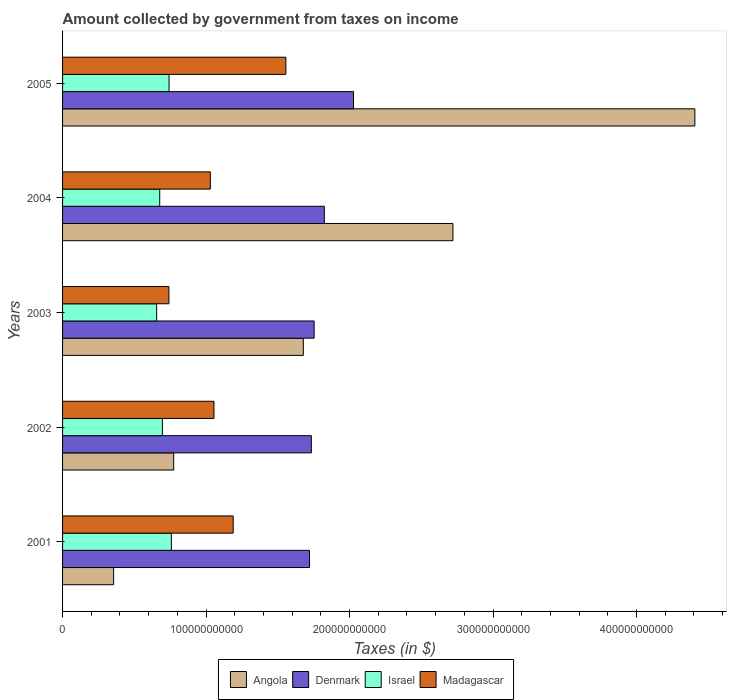How many different coloured bars are there?
Make the answer very short. 4. How many bars are there on the 2nd tick from the top?
Offer a very short reply. 4. How many bars are there on the 2nd tick from the bottom?
Provide a succinct answer. 4. What is the amount collected by government from taxes on income in Denmark in 2003?
Provide a short and direct response. 1.75e+11. Across all years, what is the maximum amount collected by government from taxes on income in Israel?
Your answer should be compact. 7.58e+1. Across all years, what is the minimum amount collected by government from taxes on income in Israel?
Keep it short and to the point. 6.56e+1. In which year was the amount collected by government from taxes on income in Israel maximum?
Give a very brief answer. 2001. What is the total amount collected by government from taxes on income in Denmark in the graph?
Your answer should be very brief. 9.06e+11. What is the difference between the amount collected by government from taxes on income in Denmark in 2003 and that in 2005?
Your answer should be very brief. -2.74e+1. What is the difference between the amount collected by government from taxes on income in Madagascar in 2001 and the amount collected by government from taxes on income in Denmark in 2002?
Give a very brief answer. -5.45e+1. What is the average amount collected by government from taxes on income in Denmark per year?
Ensure brevity in your answer.  1.81e+11. In the year 2004, what is the difference between the amount collected by government from taxes on income in Israel and amount collected by government from taxes on income in Denmark?
Give a very brief answer. -1.15e+11. In how many years, is the amount collected by government from taxes on income in Israel greater than 320000000000 $?
Give a very brief answer. 0. What is the ratio of the amount collected by government from taxes on income in Angola in 2001 to that in 2005?
Provide a short and direct response. 0.08. Is the difference between the amount collected by government from taxes on income in Israel in 2002 and 2003 greater than the difference between the amount collected by government from taxes on income in Denmark in 2002 and 2003?
Provide a succinct answer. Yes. What is the difference between the highest and the second highest amount collected by government from taxes on income in Denmark?
Give a very brief answer. 2.03e+1. What is the difference between the highest and the lowest amount collected by government from taxes on income in Madagascar?
Offer a terse response. 8.15e+1. What does the 1st bar from the bottom in 2003 represents?
Keep it short and to the point. Angola. Is it the case that in every year, the sum of the amount collected by government from taxes on income in Madagascar and amount collected by government from taxes on income in Angola is greater than the amount collected by government from taxes on income in Denmark?
Offer a very short reply. No. How many bars are there?
Offer a terse response. 20. Are all the bars in the graph horizontal?
Your answer should be very brief. Yes. What is the difference between two consecutive major ticks on the X-axis?
Your response must be concise. 1.00e+11. Are the values on the major ticks of X-axis written in scientific E-notation?
Make the answer very short. No. Where does the legend appear in the graph?
Keep it short and to the point. Bottom center. How many legend labels are there?
Your response must be concise. 4. What is the title of the graph?
Provide a short and direct response. Amount collected by government from taxes on income. What is the label or title of the X-axis?
Your response must be concise. Taxes (in $). What is the label or title of the Y-axis?
Your answer should be very brief. Years. What is the Taxes (in $) of Angola in 2001?
Ensure brevity in your answer.  3.56e+1. What is the Taxes (in $) of Denmark in 2001?
Your response must be concise. 1.72e+11. What is the Taxes (in $) of Israel in 2001?
Your answer should be very brief. 7.58e+1. What is the Taxes (in $) of Madagascar in 2001?
Provide a short and direct response. 1.19e+11. What is the Taxes (in $) in Angola in 2002?
Your answer should be compact. 7.74e+1. What is the Taxes (in $) in Denmark in 2002?
Offer a terse response. 1.73e+11. What is the Taxes (in $) in Israel in 2002?
Ensure brevity in your answer.  6.96e+1. What is the Taxes (in $) in Madagascar in 2002?
Provide a succinct answer. 1.06e+11. What is the Taxes (in $) of Angola in 2003?
Provide a short and direct response. 1.68e+11. What is the Taxes (in $) of Denmark in 2003?
Ensure brevity in your answer.  1.75e+11. What is the Taxes (in $) in Israel in 2003?
Your answer should be very brief. 6.56e+1. What is the Taxes (in $) in Madagascar in 2003?
Provide a succinct answer. 7.41e+1. What is the Taxes (in $) in Angola in 2004?
Provide a succinct answer. 2.72e+11. What is the Taxes (in $) of Denmark in 2004?
Keep it short and to the point. 1.82e+11. What is the Taxes (in $) of Israel in 2004?
Offer a terse response. 6.77e+1. What is the Taxes (in $) of Madagascar in 2004?
Your response must be concise. 1.03e+11. What is the Taxes (in $) of Angola in 2005?
Ensure brevity in your answer.  4.41e+11. What is the Taxes (in $) of Denmark in 2005?
Ensure brevity in your answer.  2.03e+11. What is the Taxes (in $) in Israel in 2005?
Offer a terse response. 7.42e+1. What is the Taxes (in $) in Madagascar in 2005?
Your response must be concise. 1.56e+11. Across all years, what is the maximum Taxes (in $) of Angola?
Provide a short and direct response. 4.41e+11. Across all years, what is the maximum Taxes (in $) in Denmark?
Provide a short and direct response. 2.03e+11. Across all years, what is the maximum Taxes (in $) of Israel?
Offer a very short reply. 7.58e+1. Across all years, what is the maximum Taxes (in $) of Madagascar?
Your response must be concise. 1.56e+11. Across all years, what is the minimum Taxes (in $) in Angola?
Give a very brief answer. 3.56e+1. Across all years, what is the minimum Taxes (in $) in Denmark?
Your response must be concise. 1.72e+11. Across all years, what is the minimum Taxes (in $) of Israel?
Provide a short and direct response. 6.56e+1. Across all years, what is the minimum Taxes (in $) of Madagascar?
Offer a terse response. 7.41e+1. What is the total Taxes (in $) of Angola in the graph?
Offer a terse response. 9.93e+11. What is the total Taxes (in $) of Denmark in the graph?
Your answer should be compact. 9.06e+11. What is the total Taxes (in $) of Israel in the graph?
Give a very brief answer. 3.53e+11. What is the total Taxes (in $) of Madagascar in the graph?
Keep it short and to the point. 5.57e+11. What is the difference between the Taxes (in $) in Angola in 2001 and that in 2002?
Your answer should be very brief. -4.19e+1. What is the difference between the Taxes (in $) in Denmark in 2001 and that in 2002?
Your answer should be compact. -1.29e+09. What is the difference between the Taxes (in $) of Israel in 2001 and that in 2002?
Offer a terse response. 6.24e+09. What is the difference between the Taxes (in $) of Madagascar in 2001 and that in 2002?
Provide a succinct answer. 1.34e+1. What is the difference between the Taxes (in $) of Angola in 2001 and that in 2003?
Provide a succinct answer. -1.32e+11. What is the difference between the Taxes (in $) of Denmark in 2001 and that in 2003?
Make the answer very short. -3.24e+09. What is the difference between the Taxes (in $) of Israel in 2001 and that in 2003?
Your answer should be compact. 1.03e+1. What is the difference between the Taxes (in $) in Madagascar in 2001 and that in 2003?
Provide a short and direct response. 4.48e+1. What is the difference between the Taxes (in $) in Angola in 2001 and that in 2004?
Give a very brief answer. -2.36e+11. What is the difference between the Taxes (in $) of Denmark in 2001 and that in 2004?
Your response must be concise. -1.04e+1. What is the difference between the Taxes (in $) in Israel in 2001 and that in 2004?
Your answer should be very brief. 8.11e+09. What is the difference between the Taxes (in $) of Madagascar in 2001 and that in 2004?
Ensure brevity in your answer.  1.59e+1. What is the difference between the Taxes (in $) in Angola in 2001 and that in 2005?
Your answer should be compact. -4.05e+11. What is the difference between the Taxes (in $) of Denmark in 2001 and that in 2005?
Offer a very short reply. -3.07e+1. What is the difference between the Taxes (in $) in Israel in 2001 and that in 2005?
Your answer should be very brief. 1.62e+09. What is the difference between the Taxes (in $) in Madagascar in 2001 and that in 2005?
Provide a short and direct response. -3.67e+1. What is the difference between the Taxes (in $) in Angola in 2002 and that in 2003?
Give a very brief answer. -9.03e+1. What is the difference between the Taxes (in $) in Denmark in 2002 and that in 2003?
Offer a very short reply. -1.95e+09. What is the difference between the Taxes (in $) in Israel in 2002 and that in 2003?
Offer a very short reply. 4.01e+09. What is the difference between the Taxes (in $) of Madagascar in 2002 and that in 2003?
Your answer should be very brief. 3.14e+1. What is the difference between the Taxes (in $) in Angola in 2002 and that in 2004?
Provide a short and direct response. -1.95e+11. What is the difference between the Taxes (in $) in Denmark in 2002 and that in 2004?
Offer a very short reply. -9.06e+09. What is the difference between the Taxes (in $) in Israel in 2002 and that in 2004?
Ensure brevity in your answer.  1.87e+09. What is the difference between the Taxes (in $) of Madagascar in 2002 and that in 2004?
Your answer should be compact. 2.54e+09. What is the difference between the Taxes (in $) in Angola in 2002 and that in 2005?
Your answer should be very brief. -3.63e+11. What is the difference between the Taxes (in $) in Denmark in 2002 and that in 2005?
Ensure brevity in your answer.  -2.94e+1. What is the difference between the Taxes (in $) of Israel in 2002 and that in 2005?
Make the answer very short. -4.62e+09. What is the difference between the Taxes (in $) in Madagascar in 2002 and that in 2005?
Your answer should be compact. -5.01e+1. What is the difference between the Taxes (in $) in Angola in 2003 and that in 2004?
Offer a terse response. -1.04e+11. What is the difference between the Taxes (in $) in Denmark in 2003 and that in 2004?
Your response must be concise. -7.11e+09. What is the difference between the Taxes (in $) of Israel in 2003 and that in 2004?
Your response must be concise. -2.14e+09. What is the difference between the Taxes (in $) in Madagascar in 2003 and that in 2004?
Offer a very short reply. -2.89e+1. What is the difference between the Taxes (in $) of Angola in 2003 and that in 2005?
Ensure brevity in your answer.  -2.73e+11. What is the difference between the Taxes (in $) in Denmark in 2003 and that in 2005?
Ensure brevity in your answer.  -2.74e+1. What is the difference between the Taxes (in $) in Israel in 2003 and that in 2005?
Offer a very short reply. -8.63e+09. What is the difference between the Taxes (in $) in Madagascar in 2003 and that in 2005?
Provide a short and direct response. -8.15e+1. What is the difference between the Taxes (in $) in Angola in 2004 and that in 2005?
Offer a terse response. -1.69e+11. What is the difference between the Taxes (in $) of Denmark in 2004 and that in 2005?
Your answer should be compact. -2.03e+1. What is the difference between the Taxes (in $) of Israel in 2004 and that in 2005?
Give a very brief answer. -6.49e+09. What is the difference between the Taxes (in $) of Madagascar in 2004 and that in 2005?
Provide a succinct answer. -5.26e+1. What is the difference between the Taxes (in $) of Angola in 2001 and the Taxes (in $) of Denmark in 2002?
Offer a terse response. -1.38e+11. What is the difference between the Taxes (in $) of Angola in 2001 and the Taxes (in $) of Israel in 2002?
Offer a very short reply. -3.40e+1. What is the difference between the Taxes (in $) in Angola in 2001 and the Taxes (in $) in Madagascar in 2002?
Keep it short and to the point. -6.99e+1. What is the difference between the Taxes (in $) in Denmark in 2001 and the Taxes (in $) in Israel in 2002?
Make the answer very short. 1.02e+11. What is the difference between the Taxes (in $) of Denmark in 2001 and the Taxes (in $) of Madagascar in 2002?
Make the answer very short. 6.66e+1. What is the difference between the Taxes (in $) in Israel in 2001 and the Taxes (in $) in Madagascar in 2002?
Provide a short and direct response. -2.97e+1. What is the difference between the Taxes (in $) of Angola in 2001 and the Taxes (in $) of Denmark in 2003?
Keep it short and to the point. -1.40e+11. What is the difference between the Taxes (in $) in Angola in 2001 and the Taxes (in $) in Israel in 2003?
Make the answer very short. -3.00e+1. What is the difference between the Taxes (in $) in Angola in 2001 and the Taxes (in $) in Madagascar in 2003?
Make the answer very short. -3.85e+1. What is the difference between the Taxes (in $) in Denmark in 2001 and the Taxes (in $) in Israel in 2003?
Your answer should be very brief. 1.06e+11. What is the difference between the Taxes (in $) of Denmark in 2001 and the Taxes (in $) of Madagascar in 2003?
Your response must be concise. 9.80e+1. What is the difference between the Taxes (in $) of Israel in 2001 and the Taxes (in $) of Madagascar in 2003?
Offer a very short reply. 1.71e+09. What is the difference between the Taxes (in $) of Angola in 2001 and the Taxes (in $) of Denmark in 2004?
Keep it short and to the point. -1.47e+11. What is the difference between the Taxes (in $) in Angola in 2001 and the Taxes (in $) in Israel in 2004?
Keep it short and to the point. -3.21e+1. What is the difference between the Taxes (in $) of Angola in 2001 and the Taxes (in $) of Madagascar in 2004?
Provide a succinct answer. -6.74e+1. What is the difference between the Taxes (in $) in Denmark in 2001 and the Taxes (in $) in Israel in 2004?
Provide a short and direct response. 1.04e+11. What is the difference between the Taxes (in $) in Denmark in 2001 and the Taxes (in $) in Madagascar in 2004?
Ensure brevity in your answer.  6.91e+1. What is the difference between the Taxes (in $) in Israel in 2001 and the Taxes (in $) in Madagascar in 2004?
Make the answer very short. -2.71e+1. What is the difference between the Taxes (in $) of Angola in 2001 and the Taxes (in $) of Denmark in 2005?
Provide a short and direct response. -1.67e+11. What is the difference between the Taxes (in $) in Angola in 2001 and the Taxes (in $) in Israel in 2005?
Keep it short and to the point. -3.86e+1. What is the difference between the Taxes (in $) in Angola in 2001 and the Taxes (in $) in Madagascar in 2005?
Make the answer very short. -1.20e+11. What is the difference between the Taxes (in $) in Denmark in 2001 and the Taxes (in $) in Israel in 2005?
Your answer should be compact. 9.79e+1. What is the difference between the Taxes (in $) of Denmark in 2001 and the Taxes (in $) of Madagascar in 2005?
Ensure brevity in your answer.  1.65e+1. What is the difference between the Taxes (in $) in Israel in 2001 and the Taxes (in $) in Madagascar in 2005?
Provide a succinct answer. -7.98e+1. What is the difference between the Taxes (in $) in Angola in 2002 and the Taxes (in $) in Denmark in 2003?
Offer a terse response. -9.79e+1. What is the difference between the Taxes (in $) in Angola in 2002 and the Taxes (in $) in Israel in 2003?
Offer a terse response. 1.19e+1. What is the difference between the Taxes (in $) of Angola in 2002 and the Taxes (in $) of Madagascar in 2003?
Offer a very short reply. 3.33e+09. What is the difference between the Taxes (in $) of Denmark in 2002 and the Taxes (in $) of Israel in 2003?
Provide a short and direct response. 1.08e+11. What is the difference between the Taxes (in $) in Denmark in 2002 and the Taxes (in $) in Madagascar in 2003?
Keep it short and to the point. 9.92e+1. What is the difference between the Taxes (in $) of Israel in 2002 and the Taxes (in $) of Madagascar in 2003?
Offer a terse response. -4.53e+09. What is the difference between the Taxes (in $) of Angola in 2002 and the Taxes (in $) of Denmark in 2004?
Offer a terse response. -1.05e+11. What is the difference between the Taxes (in $) in Angola in 2002 and the Taxes (in $) in Israel in 2004?
Provide a succinct answer. 9.74e+09. What is the difference between the Taxes (in $) in Angola in 2002 and the Taxes (in $) in Madagascar in 2004?
Keep it short and to the point. -2.55e+1. What is the difference between the Taxes (in $) in Denmark in 2002 and the Taxes (in $) in Israel in 2004?
Provide a succinct answer. 1.06e+11. What is the difference between the Taxes (in $) in Denmark in 2002 and the Taxes (in $) in Madagascar in 2004?
Give a very brief answer. 7.04e+1. What is the difference between the Taxes (in $) of Israel in 2002 and the Taxes (in $) of Madagascar in 2004?
Your answer should be compact. -3.34e+1. What is the difference between the Taxes (in $) in Angola in 2002 and the Taxes (in $) in Denmark in 2005?
Offer a terse response. -1.25e+11. What is the difference between the Taxes (in $) of Angola in 2002 and the Taxes (in $) of Israel in 2005?
Your response must be concise. 3.25e+09. What is the difference between the Taxes (in $) in Angola in 2002 and the Taxes (in $) in Madagascar in 2005?
Your answer should be very brief. -7.82e+1. What is the difference between the Taxes (in $) of Denmark in 2002 and the Taxes (in $) of Israel in 2005?
Give a very brief answer. 9.92e+1. What is the difference between the Taxes (in $) of Denmark in 2002 and the Taxes (in $) of Madagascar in 2005?
Ensure brevity in your answer.  1.78e+1. What is the difference between the Taxes (in $) of Israel in 2002 and the Taxes (in $) of Madagascar in 2005?
Offer a very short reply. -8.60e+1. What is the difference between the Taxes (in $) of Angola in 2003 and the Taxes (in $) of Denmark in 2004?
Provide a succinct answer. -1.46e+1. What is the difference between the Taxes (in $) in Angola in 2003 and the Taxes (in $) in Israel in 2004?
Provide a short and direct response. 1.00e+11. What is the difference between the Taxes (in $) in Angola in 2003 and the Taxes (in $) in Madagascar in 2004?
Offer a terse response. 6.48e+1. What is the difference between the Taxes (in $) of Denmark in 2003 and the Taxes (in $) of Israel in 2004?
Provide a succinct answer. 1.08e+11. What is the difference between the Taxes (in $) of Denmark in 2003 and the Taxes (in $) of Madagascar in 2004?
Give a very brief answer. 7.23e+1. What is the difference between the Taxes (in $) in Israel in 2003 and the Taxes (in $) in Madagascar in 2004?
Ensure brevity in your answer.  -3.74e+1. What is the difference between the Taxes (in $) in Angola in 2003 and the Taxes (in $) in Denmark in 2005?
Your response must be concise. -3.50e+1. What is the difference between the Taxes (in $) in Angola in 2003 and the Taxes (in $) in Israel in 2005?
Keep it short and to the point. 9.36e+1. What is the difference between the Taxes (in $) in Angola in 2003 and the Taxes (in $) in Madagascar in 2005?
Give a very brief answer. 1.22e+1. What is the difference between the Taxes (in $) of Denmark in 2003 and the Taxes (in $) of Israel in 2005?
Your answer should be compact. 1.01e+11. What is the difference between the Taxes (in $) in Denmark in 2003 and the Taxes (in $) in Madagascar in 2005?
Make the answer very short. 1.97e+1. What is the difference between the Taxes (in $) of Israel in 2003 and the Taxes (in $) of Madagascar in 2005?
Offer a very short reply. -9.00e+1. What is the difference between the Taxes (in $) of Angola in 2004 and the Taxes (in $) of Denmark in 2005?
Your answer should be very brief. 6.93e+1. What is the difference between the Taxes (in $) of Angola in 2004 and the Taxes (in $) of Israel in 2005?
Your answer should be very brief. 1.98e+11. What is the difference between the Taxes (in $) of Angola in 2004 and the Taxes (in $) of Madagascar in 2005?
Give a very brief answer. 1.16e+11. What is the difference between the Taxes (in $) in Denmark in 2004 and the Taxes (in $) in Israel in 2005?
Your answer should be compact. 1.08e+11. What is the difference between the Taxes (in $) in Denmark in 2004 and the Taxes (in $) in Madagascar in 2005?
Keep it short and to the point. 2.68e+1. What is the difference between the Taxes (in $) in Israel in 2004 and the Taxes (in $) in Madagascar in 2005?
Your answer should be very brief. -8.79e+1. What is the average Taxes (in $) of Angola per year?
Keep it short and to the point. 1.99e+11. What is the average Taxes (in $) of Denmark per year?
Provide a short and direct response. 1.81e+11. What is the average Taxes (in $) in Israel per year?
Offer a very short reply. 7.06e+1. What is the average Taxes (in $) of Madagascar per year?
Offer a terse response. 1.11e+11. In the year 2001, what is the difference between the Taxes (in $) of Angola and Taxes (in $) of Denmark?
Your answer should be compact. -1.36e+11. In the year 2001, what is the difference between the Taxes (in $) of Angola and Taxes (in $) of Israel?
Provide a succinct answer. -4.02e+1. In the year 2001, what is the difference between the Taxes (in $) of Angola and Taxes (in $) of Madagascar?
Offer a very short reply. -8.33e+1. In the year 2001, what is the difference between the Taxes (in $) of Denmark and Taxes (in $) of Israel?
Make the answer very short. 9.62e+1. In the year 2001, what is the difference between the Taxes (in $) in Denmark and Taxes (in $) in Madagascar?
Offer a very short reply. 5.32e+1. In the year 2001, what is the difference between the Taxes (in $) in Israel and Taxes (in $) in Madagascar?
Provide a succinct answer. -4.31e+1. In the year 2002, what is the difference between the Taxes (in $) of Angola and Taxes (in $) of Denmark?
Give a very brief answer. -9.59e+1. In the year 2002, what is the difference between the Taxes (in $) in Angola and Taxes (in $) in Israel?
Provide a succinct answer. 7.87e+09. In the year 2002, what is the difference between the Taxes (in $) of Angola and Taxes (in $) of Madagascar?
Make the answer very short. -2.81e+1. In the year 2002, what is the difference between the Taxes (in $) in Denmark and Taxes (in $) in Israel?
Provide a short and direct response. 1.04e+11. In the year 2002, what is the difference between the Taxes (in $) in Denmark and Taxes (in $) in Madagascar?
Keep it short and to the point. 6.79e+1. In the year 2002, what is the difference between the Taxes (in $) in Israel and Taxes (in $) in Madagascar?
Offer a very short reply. -3.59e+1. In the year 2003, what is the difference between the Taxes (in $) of Angola and Taxes (in $) of Denmark?
Give a very brief answer. -7.53e+09. In the year 2003, what is the difference between the Taxes (in $) in Angola and Taxes (in $) in Israel?
Your response must be concise. 1.02e+11. In the year 2003, what is the difference between the Taxes (in $) in Angola and Taxes (in $) in Madagascar?
Make the answer very short. 9.37e+1. In the year 2003, what is the difference between the Taxes (in $) in Denmark and Taxes (in $) in Israel?
Ensure brevity in your answer.  1.10e+11. In the year 2003, what is the difference between the Taxes (in $) of Denmark and Taxes (in $) of Madagascar?
Provide a short and direct response. 1.01e+11. In the year 2003, what is the difference between the Taxes (in $) in Israel and Taxes (in $) in Madagascar?
Keep it short and to the point. -8.54e+09. In the year 2004, what is the difference between the Taxes (in $) in Angola and Taxes (in $) in Denmark?
Your answer should be compact. 8.96e+1. In the year 2004, what is the difference between the Taxes (in $) of Angola and Taxes (in $) of Israel?
Make the answer very short. 2.04e+11. In the year 2004, what is the difference between the Taxes (in $) of Angola and Taxes (in $) of Madagascar?
Provide a succinct answer. 1.69e+11. In the year 2004, what is the difference between the Taxes (in $) of Denmark and Taxes (in $) of Israel?
Your answer should be compact. 1.15e+11. In the year 2004, what is the difference between the Taxes (in $) of Denmark and Taxes (in $) of Madagascar?
Your answer should be very brief. 7.94e+1. In the year 2004, what is the difference between the Taxes (in $) of Israel and Taxes (in $) of Madagascar?
Your response must be concise. -3.53e+1. In the year 2005, what is the difference between the Taxes (in $) of Angola and Taxes (in $) of Denmark?
Provide a short and direct response. 2.38e+11. In the year 2005, what is the difference between the Taxes (in $) of Angola and Taxes (in $) of Israel?
Give a very brief answer. 3.66e+11. In the year 2005, what is the difference between the Taxes (in $) in Angola and Taxes (in $) in Madagascar?
Ensure brevity in your answer.  2.85e+11. In the year 2005, what is the difference between the Taxes (in $) of Denmark and Taxes (in $) of Israel?
Your response must be concise. 1.29e+11. In the year 2005, what is the difference between the Taxes (in $) in Denmark and Taxes (in $) in Madagascar?
Offer a very short reply. 4.71e+1. In the year 2005, what is the difference between the Taxes (in $) of Israel and Taxes (in $) of Madagascar?
Give a very brief answer. -8.14e+1. What is the ratio of the Taxes (in $) in Angola in 2001 to that in 2002?
Give a very brief answer. 0.46. What is the ratio of the Taxes (in $) in Israel in 2001 to that in 2002?
Offer a terse response. 1.09. What is the ratio of the Taxes (in $) of Madagascar in 2001 to that in 2002?
Your response must be concise. 1.13. What is the ratio of the Taxes (in $) of Angola in 2001 to that in 2003?
Provide a short and direct response. 0.21. What is the ratio of the Taxes (in $) in Denmark in 2001 to that in 2003?
Make the answer very short. 0.98. What is the ratio of the Taxes (in $) in Israel in 2001 to that in 2003?
Your answer should be very brief. 1.16. What is the ratio of the Taxes (in $) in Madagascar in 2001 to that in 2003?
Give a very brief answer. 1.6. What is the ratio of the Taxes (in $) of Angola in 2001 to that in 2004?
Your answer should be compact. 0.13. What is the ratio of the Taxes (in $) in Denmark in 2001 to that in 2004?
Give a very brief answer. 0.94. What is the ratio of the Taxes (in $) in Israel in 2001 to that in 2004?
Make the answer very short. 1.12. What is the ratio of the Taxes (in $) of Madagascar in 2001 to that in 2004?
Your answer should be compact. 1.15. What is the ratio of the Taxes (in $) of Angola in 2001 to that in 2005?
Your response must be concise. 0.08. What is the ratio of the Taxes (in $) of Denmark in 2001 to that in 2005?
Offer a very short reply. 0.85. What is the ratio of the Taxes (in $) in Israel in 2001 to that in 2005?
Give a very brief answer. 1.02. What is the ratio of the Taxes (in $) of Madagascar in 2001 to that in 2005?
Your answer should be very brief. 0.76. What is the ratio of the Taxes (in $) of Angola in 2002 to that in 2003?
Keep it short and to the point. 0.46. What is the ratio of the Taxes (in $) of Denmark in 2002 to that in 2003?
Offer a very short reply. 0.99. What is the ratio of the Taxes (in $) in Israel in 2002 to that in 2003?
Your response must be concise. 1.06. What is the ratio of the Taxes (in $) of Madagascar in 2002 to that in 2003?
Keep it short and to the point. 1.42. What is the ratio of the Taxes (in $) in Angola in 2002 to that in 2004?
Make the answer very short. 0.28. What is the ratio of the Taxes (in $) of Denmark in 2002 to that in 2004?
Offer a very short reply. 0.95. What is the ratio of the Taxes (in $) of Israel in 2002 to that in 2004?
Your answer should be very brief. 1.03. What is the ratio of the Taxes (in $) in Madagascar in 2002 to that in 2004?
Provide a short and direct response. 1.02. What is the ratio of the Taxes (in $) of Angola in 2002 to that in 2005?
Offer a terse response. 0.18. What is the ratio of the Taxes (in $) of Denmark in 2002 to that in 2005?
Provide a succinct answer. 0.86. What is the ratio of the Taxes (in $) of Israel in 2002 to that in 2005?
Your answer should be very brief. 0.94. What is the ratio of the Taxes (in $) in Madagascar in 2002 to that in 2005?
Offer a terse response. 0.68. What is the ratio of the Taxes (in $) of Angola in 2003 to that in 2004?
Your response must be concise. 0.62. What is the ratio of the Taxes (in $) in Denmark in 2003 to that in 2004?
Provide a succinct answer. 0.96. What is the ratio of the Taxes (in $) in Israel in 2003 to that in 2004?
Your answer should be very brief. 0.97. What is the ratio of the Taxes (in $) of Madagascar in 2003 to that in 2004?
Keep it short and to the point. 0.72. What is the ratio of the Taxes (in $) of Angola in 2003 to that in 2005?
Ensure brevity in your answer.  0.38. What is the ratio of the Taxes (in $) in Denmark in 2003 to that in 2005?
Provide a short and direct response. 0.86. What is the ratio of the Taxes (in $) of Israel in 2003 to that in 2005?
Keep it short and to the point. 0.88. What is the ratio of the Taxes (in $) of Madagascar in 2003 to that in 2005?
Offer a terse response. 0.48. What is the ratio of the Taxes (in $) of Angola in 2004 to that in 2005?
Offer a very short reply. 0.62. What is the ratio of the Taxes (in $) of Denmark in 2004 to that in 2005?
Offer a terse response. 0.9. What is the ratio of the Taxes (in $) of Israel in 2004 to that in 2005?
Your answer should be compact. 0.91. What is the ratio of the Taxes (in $) of Madagascar in 2004 to that in 2005?
Provide a short and direct response. 0.66. What is the difference between the highest and the second highest Taxes (in $) in Angola?
Make the answer very short. 1.69e+11. What is the difference between the highest and the second highest Taxes (in $) in Denmark?
Offer a terse response. 2.03e+1. What is the difference between the highest and the second highest Taxes (in $) in Israel?
Offer a terse response. 1.62e+09. What is the difference between the highest and the second highest Taxes (in $) in Madagascar?
Your answer should be compact. 3.67e+1. What is the difference between the highest and the lowest Taxes (in $) of Angola?
Make the answer very short. 4.05e+11. What is the difference between the highest and the lowest Taxes (in $) of Denmark?
Offer a very short reply. 3.07e+1. What is the difference between the highest and the lowest Taxes (in $) of Israel?
Your answer should be very brief. 1.03e+1. What is the difference between the highest and the lowest Taxes (in $) in Madagascar?
Provide a succinct answer. 8.15e+1. 